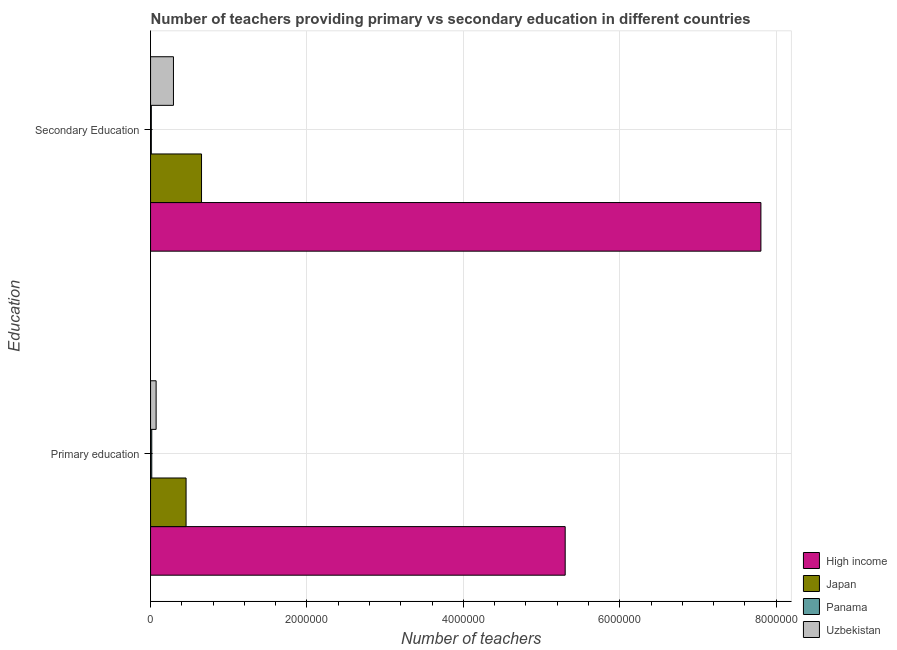How many different coloured bars are there?
Provide a succinct answer. 4. Are the number of bars per tick equal to the number of legend labels?
Keep it short and to the point. Yes. Are the number of bars on each tick of the Y-axis equal?
Offer a very short reply. Yes. What is the label of the 1st group of bars from the top?
Make the answer very short. Secondary Education. What is the number of secondary teachers in Japan?
Offer a very short reply. 6.52e+05. Across all countries, what is the maximum number of primary teachers?
Provide a succinct answer. 5.30e+06. Across all countries, what is the minimum number of secondary teachers?
Make the answer very short. 9754. In which country was the number of primary teachers maximum?
Offer a very short reply. High income. In which country was the number of secondary teachers minimum?
Offer a terse response. Panama. What is the total number of primary teachers in the graph?
Your answer should be very brief. 5.84e+06. What is the difference between the number of secondary teachers in High income and that in Japan?
Keep it short and to the point. 7.15e+06. What is the difference between the number of primary teachers in Uzbekistan and the number of secondary teachers in High income?
Your answer should be compact. -7.73e+06. What is the average number of primary teachers per country?
Keep it short and to the point. 1.46e+06. What is the difference between the number of secondary teachers and number of primary teachers in Japan?
Give a very brief answer. 1.98e+05. What is the ratio of the number of secondary teachers in High income to that in Uzbekistan?
Make the answer very short. 26.68. Is the number of primary teachers in High income less than that in Uzbekistan?
Your answer should be compact. No. In how many countries, is the number of secondary teachers greater than the average number of secondary teachers taken over all countries?
Give a very brief answer. 1. What does the 1st bar from the top in Primary education represents?
Your answer should be compact. Uzbekistan. What does the 4th bar from the bottom in Primary education represents?
Ensure brevity in your answer.  Uzbekistan. Are the values on the major ticks of X-axis written in scientific E-notation?
Make the answer very short. No. Does the graph contain any zero values?
Make the answer very short. No. Does the graph contain grids?
Provide a short and direct response. Yes. Where does the legend appear in the graph?
Offer a terse response. Bottom right. How many legend labels are there?
Offer a terse response. 4. What is the title of the graph?
Make the answer very short. Number of teachers providing primary vs secondary education in different countries. What is the label or title of the X-axis?
Your response must be concise. Number of teachers. What is the label or title of the Y-axis?
Provide a succinct answer. Education. What is the Number of teachers in High income in Primary education?
Your response must be concise. 5.30e+06. What is the Number of teachers of Japan in Primary education?
Offer a terse response. 4.54e+05. What is the Number of teachers of Panama in Primary education?
Ensure brevity in your answer.  1.52e+04. What is the Number of teachers in Uzbekistan in Primary education?
Offer a terse response. 7.10e+04. What is the Number of teachers in High income in Secondary Education?
Give a very brief answer. 7.81e+06. What is the Number of teachers in Japan in Secondary Education?
Offer a terse response. 6.52e+05. What is the Number of teachers of Panama in Secondary Education?
Provide a succinct answer. 9754. What is the Number of teachers of Uzbekistan in Secondary Education?
Provide a succinct answer. 2.93e+05. Across all Education, what is the maximum Number of teachers of High income?
Your answer should be very brief. 7.81e+06. Across all Education, what is the maximum Number of teachers in Japan?
Offer a terse response. 6.52e+05. Across all Education, what is the maximum Number of teachers in Panama?
Offer a very short reply. 1.52e+04. Across all Education, what is the maximum Number of teachers of Uzbekistan?
Your answer should be compact. 2.93e+05. Across all Education, what is the minimum Number of teachers in High income?
Offer a terse response. 5.30e+06. Across all Education, what is the minimum Number of teachers of Japan?
Keep it short and to the point. 4.54e+05. Across all Education, what is the minimum Number of teachers of Panama?
Keep it short and to the point. 9754. Across all Education, what is the minimum Number of teachers of Uzbekistan?
Ensure brevity in your answer.  7.10e+04. What is the total Number of teachers in High income in the graph?
Ensure brevity in your answer.  1.31e+07. What is the total Number of teachers in Japan in the graph?
Give a very brief answer. 1.11e+06. What is the total Number of teachers of Panama in the graph?
Your answer should be compact. 2.50e+04. What is the total Number of teachers of Uzbekistan in the graph?
Offer a terse response. 3.64e+05. What is the difference between the Number of teachers in High income in Primary education and that in Secondary Education?
Keep it short and to the point. -2.50e+06. What is the difference between the Number of teachers of Japan in Primary education and that in Secondary Education?
Your response must be concise. -1.98e+05. What is the difference between the Number of teachers in Panama in Primary education and that in Secondary Education?
Your response must be concise. 5495. What is the difference between the Number of teachers of Uzbekistan in Primary education and that in Secondary Education?
Provide a succinct answer. -2.22e+05. What is the difference between the Number of teachers in High income in Primary education and the Number of teachers in Japan in Secondary Education?
Keep it short and to the point. 4.65e+06. What is the difference between the Number of teachers in High income in Primary education and the Number of teachers in Panama in Secondary Education?
Ensure brevity in your answer.  5.29e+06. What is the difference between the Number of teachers of High income in Primary education and the Number of teachers of Uzbekistan in Secondary Education?
Ensure brevity in your answer.  5.01e+06. What is the difference between the Number of teachers in Japan in Primary education and the Number of teachers in Panama in Secondary Education?
Offer a terse response. 4.44e+05. What is the difference between the Number of teachers of Japan in Primary education and the Number of teachers of Uzbekistan in Secondary Education?
Provide a short and direct response. 1.62e+05. What is the difference between the Number of teachers in Panama in Primary education and the Number of teachers in Uzbekistan in Secondary Education?
Your response must be concise. -2.77e+05. What is the average Number of teachers of High income per Education?
Your response must be concise. 6.55e+06. What is the average Number of teachers of Japan per Education?
Your response must be concise. 5.53e+05. What is the average Number of teachers of Panama per Education?
Keep it short and to the point. 1.25e+04. What is the average Number of teachers in Uzbekistan per Education?
Give a very brief answer. 1.82e+05. What is the difference between the Number of teachers in High income and Number of teachers in Japan in Primary education?
Offer a terse response. 4.85e+06. What is the difference between the Number of teachers in High income and Number of teachers in Panama in Primary education?
Ensure brevity in your answer.  5.29e+06. What is the difference between the Number of teachers in High income and Number of teachers in Uzbekistan in Primary education?
Ensure brevity in your answer.  5.23e+06. What is the difference between the Number of teachers of Japan and Number of teachers of Panama in Primary education?
Provide a succinct answer. 4.39e+05. What is the difference between the Number of teachers in Japan and Number of teachers in Uzbekistan in Primary education?
Offer a terse response. 3.83e+05. What is the difference between the Number of teachers of Panama and Number of teachers of Uzbekistan in Primary education?
Your response must be concise. -5.58e+04. What is the difference between the Number of teachers of High income and Number of teachers of Japan in Secondary Education?
Your answer should be compact. 7.15e+06. What is the difference between the Number of teachers of High income and Number of teachers of Panama in Secondary Education?
Give a very brief answer. 7.80e+06. What is the difference between the Number of teachers of High income and Number of teachers of Uzbekistan in Secondary Education?
Offer a terse response. 7.51e+06. What is the difference between the Number of teachers in Japan and Number of teachers in Panama in Secondary Education?
Provide a succinct answer. 6.42e+05. What is the difference between the Number of teachers of Japan and Number of teachers of Uzbekistan in Secondary Education?
Give a very brief answer. 3.59e+05. What is the difference between the Number of teachers in Panama and Number of teachers in Uzbekistan in Secondary Education?
Your answer should be very brief. -2.83e+05. What is the ratio of the Number of teachers of High income in Primary education to that in Secondary Education?
Offer a very short reply. 0.68. What is the ratio of the Number of teachers in Japan in Primary education to that in Secondary Education?
Ensure brevity in your answer.  0.7. What is the ratio of the Number of teachers of Panama in Primary education to that in Secondary Education?
Your answer should be compact. 1.56. What is the ratio of the Number of teachers of Uzbekistan in Primary education to that in Secondary Education?
Keep it short and to the point. 0.24. What is the difference between the highest and the second highest Number of teachers in High income?
Your answer should be very brief. 2.50e+06. What is the difference between the highest and the second highest Number of teachers in Japan?
Offer a very short reply. 1.98e+05. What is the difference between the highest and the second highest Number of teachers of Panama?
Offer a terse response. 5495. What is the difference between the highest and the second highest Number of teachers in Uzbekistan?
Offer a terse response. 2.22e+05. What is the difference between the highest and the lowest Number of teachers of High income?
Give a very brief answer. 2.50e+06. What is the difference between the highest and the lowest Number of teachers in Japan?
Offer a very short reply. 1.98e+05. What is the difference between the highest and the lowest Number of teachers of Panama?
Ensure brevity in your answer.  5495. What is the difference between the highest and the lowest Number of teachers of Uzbekistan?
Offer a terse response. 2.22e+05. 